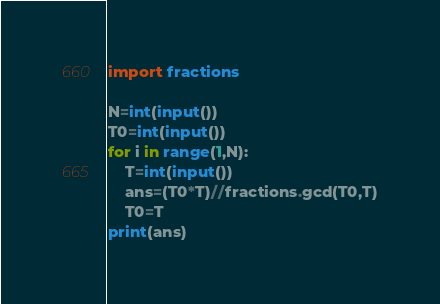<code> <loc_0><loc_0><loc_500><loc_500><_Python_>import fractions

N=int(input())
T0=int(input())
for i in range(1,N):
    T=int(input())
    ans=(T0*T)//fractions.gcd(T0,T)
    T0=T
print(ans)</code> 